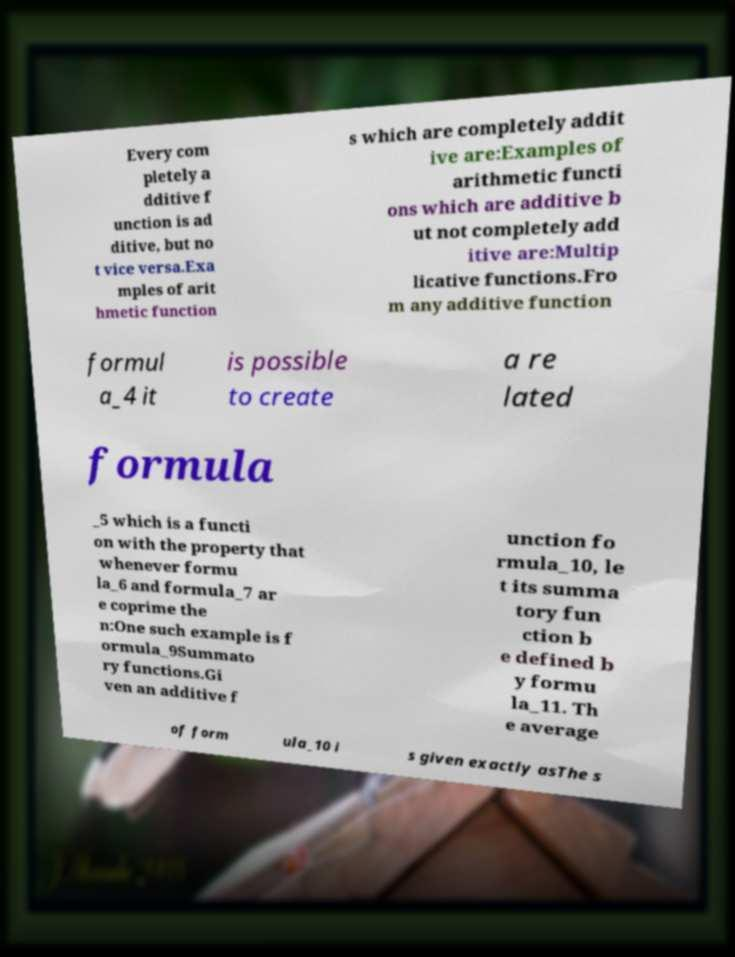For documentation purposes, I need the text within this image transcribed. Could you provide that? Every com pletely a dditive f unction is ad ditive, but no t vice versa.Exa mples of arit hmetic function s which are completely addit ive are:Examples of arithmetic functi ons which are additive b ut not completely add itive are:Multip licative functions.Fro m any additive function formul a_4 it is possible to create a re lated formula _5 which is a functi on with the property that whenever formu la_6 and formula_7 ar e coprime the n:One such example is f ormula_9Summato ry functions.Gi ven an additive f unction fo rmula_10, le t its summa tory fun ction b e defined b y formu la_11. Th e average of form ula_10 i s given exactly asThe s 